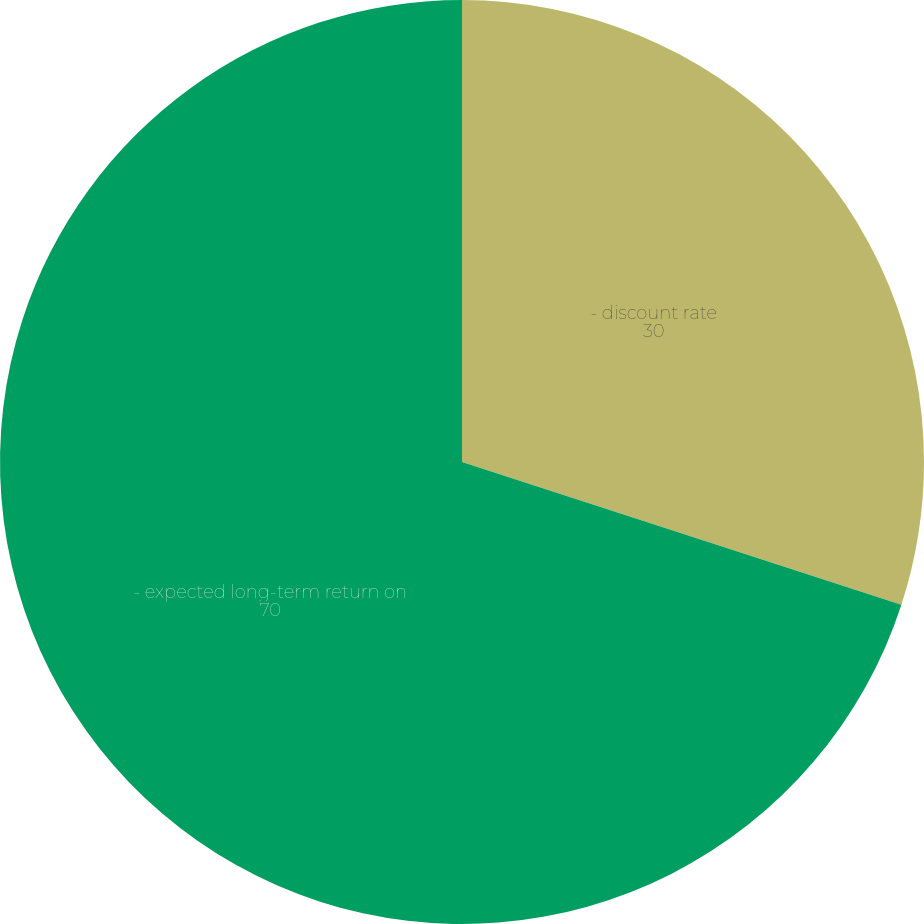Convert chart. <chart><loc_0><loc_0><loc_500><loc_500><pie_chart><fcel>- discount rate<fcel>- expected long-term return on<nl><fcel>30.0%<fcel>70.0%<nl></chart> 